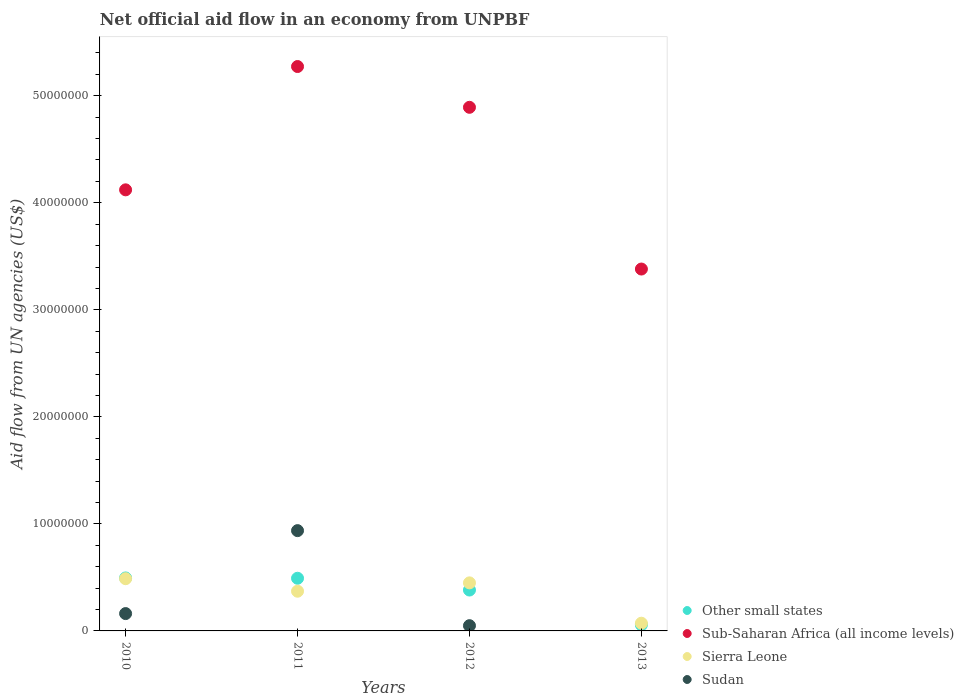Is the number of dotlines equal to the number of legend labels?
Your response must be concise. No. What is the net official aid flow in Sudan in 2011?
Keep it short and to the point. 9.37e+06. Across all years, what is the maximum net official aid flow in Sierra Leone?
Ensure brevity in your answer.  4.88e+06. Across all years, what is the minimum net official aid flow in Sierra Leone?
Provide a short and direct response. 7.20e+05. In which year was the net official aid flow in Sudan maximum?
Keep it short and to the point. 2011. What is the total net official aid flow in Sub-Saharan Africa (all income levels) in the graph?
Offer a very short reply. 1.77e+08. What is the difference between the net official aid flow in Sierra Leone in 2010 and that in 2011?
Make the answer very short. 1.17e+06. What is the difference between the net official aid flow in Sub-Saharan Africa (all income levels) in 2011 and the net official aid flow in Sudan in 2012?
Your response must be concise. 5.22e+07. What is the average net official aid flow in Other small states per year?
Keep it short and to the point. 3.56e+06. In the year 2012, what is the difference between the net official aid flow in Sudan and net official aid flow in Sierra Leone?
Offer a terse response. -4.00e+06. What is the ratio of the net official aid flow in Sierra Leone in 2012 to that in 2013?
Your response must be concise. 6.24. Is the net official aid flow in Other small states in 2012 less than that in 2013?
Keep it short and to the point. No. Is the difference between the net official aid flow in Sudan in 2011 and 2012 greater than the difference between the net official aid flow in Sierra Leone in 2011 and 2012?
Provide a short and direct response. Yes. What is the difference between the highest and the second highest net official aid flow in Sub-Saharan Africa (all income levels)?
Offer a very short reply. 3.81e+06. What is the difference between the highest and the lowest net official aid flow in Other small states?
Offer a terse response. 4.38e+06. Is it the case that in every year, the sum of the net official aid flow in Sierra Leone and net official aid flow in Sudan  is greater than the sum of net official aid flow in Other small states and net official aid flow in Sub-Saharan Africa (all income levels)?
Provide a succinct answer. No. Is the net official aid flow in Sierra Leone strictly less than the net official aid flow in Sub-Saharan Africa (all income levels) over the years?
Keep it short and to the point. Yes. Does the graph contain any zero values?
Your response must be concise. Yes. Does the graph contain grids?
Keep it short and to the point. No. Where does the legend appear in the graph?
Give a very brief answer. Bottom right. How are the legend labels stacked?
Provide a succinct answer. Vertical. What is the title of the graph?
Your answer should be compact. Net official aid flow in an economy from UNPBF. Does "Maldives" appear as one of the legend labels in the graph?
Ensure brevity in your answer.  No. What is the label or title of the X-axis?
Your answer should be very brief. Years. What is the label or title of the Y-axis?
Your answer should be very brief. Aid flow from UN agencies (US$). What is the Aid flow from UN agencies (US$) of Other small states in 2010?
Your response must be concise. 4.95e+06. What is the Aid flow from UN agencies (US$) in Sub-Saharan Africa (all income levels) in 2010?
Your answer should be very brief. 4.12e+07. What is the Aid flow from UN agencies (US$) in Sierra Leone in 2010?
Offer a very short reply. 4.88e+06. What is the Aid flow from UN agencies (US$) in Sudan in 2010?
Ensure brevity in your answer.  1.62e+06. What is the Aid flow from UN agencies (US$) of Other small states in 2011?
Provide a succinct answer. 4.92e+06. What is the Aid flow from UN agencies (US$) in Sub-Saharan Africa (all income levels) in 2011?
Your answer should be very brief. 5.27e+07. What is the Aid flow from UN agencies (US$) in Sierra Leone in 2011?
Your answer should be compact. 3.71e+06. What is the Aid flow from UN agencies (US$) of Sudan in 2011?
Make the answer very short. 9.37e+06. What is the Aid flow from UN agencies (US$) of Other small states in 2012?
Provide a short and direct response. 3.82e+06. What is the Aid flow from UN agencies (US$) in Sub-Saharan Africa (all income levels) in 2012?
Your response must be concise. 4.89e+07. What is the Aid flow from UN agencies (US$) of Sierra Leone in 2012?
Offer a terse response. 4.49e+06. What is the Aid flow from UN agencies (US$) in Sudan in 2012?
Provide a short and direct response. 4.90e+05. What is the Aid flow from UN agencies (US$) of Other small states in 2013?
Make the answer very short. 5.70e+05. What is the Aid flow from UN agencies (US$) of Sub-Saharan Africa (all income levels) in 2013?
Your response must be concise. 3.38e+07. What is the Aid flow from UN agencies (US$) in Sierra Leone in 2013?
Keep it short and to the point. 7.20e+05. Across all years, what is the maximum Aid flow from UN agencies (US$) in Other small states?
Provide a succinct answer. 4.95e+06. Across all years, what is the maximum Aid flow from UN agencies (US$) in Sub-Saharan Africa (all income levels)?
Provide a succinct answer. 5.27e+07. Across all years, what is the maximum Aid flow from UN agencies (US$) of Sierra Leone?
Your answer should be very brief. 4.88e+06. Across all years, what is the maximum Aid flow from UN agencies (US$) in Sudan?
Offer a very short reply. 9.37e+06. Across all years, what is the minimum Aid flow from UN agencies (US$) of Other small states?
Offer a very short reply. 5.70e+05. Across all years, what is the minimum Aid flow from UN agencies (US$) of Sub-Saharan Africa (all income levels)?
Offer a very short reply. 3.38e+07. Across all years, what is the minimum Aid flow from UN agencies (US$) in Sierra Leone?
Keep it short and to the point. 7.20e+05. Across all years, what is the minimum Aid flow from UN agencies (US$) of Sudan?
Provide a short and direct response. 0. What is the total Aid flow from UN agencies (US$) of Other small states in the graph?
Give a very brief answer. 1.43e+07. What is the total Aid flow from UN agencies (US$) of Sub-Saharan Africa (all income levels) in the graph?
Keep it short and to the point. 1.77e+08. What is the total Aid flow from UN agencies (US$) in Sierra Leone in the graph?
Keep it short and to the point. 1.38e+07. What is the total Aid flow from UN agencies (US$) of Sudan in the graph?
Your answer should be very brief. 1.15e+07. What is the difference between the Aid flow from UN agencies (US$) of Other small states in 2010 and that in 2011?
Provide a succinct answer. 3.00e+04. What is the difference between the Aid flow from UN agencies (US$) of Sub-Saharan Africa (all income levels) in 2010 and that in 2011?
Offer a terse response. -1.15e+07. What is the difference between the Aid flow from UN agencies (US$) of Sierra Leone in 2010 and that in 2011?
Offer a very short reply. 1.17e+06. What is the difference between the Aid flow from UN agencies (US$) of Sudan in 2010 and that in 2011?
Make the answer very short. -7.75e+06. What is the difference between the Aid flow from UN agencies (US$) of Other small states in 2010 and that in 2012?
Ensure brevity in your answer.  1.13e+06. What is the difference between the Aid flow from UN agencies (US$) in Sub-Saharan Africa (all income levels) in 2010 and that in 2012?
Offer a terse response. -7.71e+06. What is the difference between the Aid flow from UN agencies (US$) of Sierra Leone in 2010 and that in 2012?
Give a very brief answer. 3.90e+05. What is the difference between the Aid flow from UN agencies (US$) of Sudan in 2010 and that in 2012?
Ensure brevity in your answer.  1.13e+06. What is the difference between the Aid flow from UN agencies (US$) in Other small states in 2010 and that in 2013?
Make the answer very short. 4.38e+06. What is the difference between the Aid flow from UN agencies (US$) of Sub-Saharan Africa (all income levels) in 2010 and that in 2013?
Your response must be concise. 7.40e+06. What is the difference between the Aid flow from UN agencies (US$) of Sierra Leone in 2010 and that in 2013?
Make the answer very short. 4.16e+06. What is the difference between the Aid flow from UN agencies (US$) in Other small states in 2011 and that in 2012?
Give a very brief answer. 1.10e+06. What is the difference between the Aid flow from UN agencies (US$) in Sub-Saharan Africa (all income levels) in 2011 and that in 2012?
Provide a succinct answer. 3.81e+06. What is the difference between the Aid flow from UN agencies (US$) of Sierra Leone in 2011 and that in 2012?
Offer a very short reply. -7.80e+05. What is the difference between the Aid flow from UN agencies (US$) of Sudan in 2011 and that in 2012?
Make the answer very short. 8.88e+06. What is the difference between the Aid flow from UN agencies (US$) of Other small states in 2011 and that in 2013?
Keep it short and to the point. 4.35e+06. What is the difference between the Aid flow from UN agencies (US$) of Sub-Saharan Africa (all income levels) in 2011 and that in 2013?
Provide a succinct answer. 1.89e+07. What is the difference between the Aid flow from UN agencies (US$) in Sierra Leone in 2011 and that in 2013?
Your response must be concise. 2.99e+06. What is the difference between the Aid flow from UN agencies (US$) in Other small states in 2012 and that in 2013?
Your answer should be very brief. 3.25e+06. What is the difference between the Aid flow from UN agencies (US$) of Sub-Saharan Africa (all income levels) in 2012 and that in 2013?
Make the answer very short. 1.51e+07. What is the difference between the Aid flow from UN agencies (US$) of Sierra Leone in 2012 and that in 2013?
Offer a very short reply. 3.77e+06. What is the difference between the Aid flow from UN agencies (US$) in Other small states in 2010 and the Aid flow from UN agencies (US$) in Sub-Saharan Africa (all income levels) in 2011?
Make the answer very short. -4.78e+07. What is the difference between the Aid flow from UN agencies (US$) in Other small states in 2010 and the Aid flow from UN agencies (US$) in Sierra Leone in 2011?
Make the answer very short. 1.24e+06. What is the difference between the Aid flow from UN agencies (US$) in Other small states in 2010 and the Aid flow from UN agencies (US$) in Sudan in 2011?
Provide a succinct answer. -4.42e+06. What is the difference between the Aid flow from UN agencies (US$) in Sub-Saharan Africa (all income levels) in 2010 and the Aid flow from UN agencies (US$) in Sierra Leone in 2011?
Offer a terse response. 3.75e+07. What is the difference between the Aid flow from UN agencies (US$) in Sub-Saharan Africa (all income levels) in 2010 and the Aid flow from UN agencies (US$) in Sudan in 2011?
Your answer should be compact. 3.18e+07. What is the difference between the Aid flow from UN agencies (US$) of Sierra Leone in 2010 and the Aid flow from UN agencies (US$) of Sudan in 2011?
Provide a short and direct response. -4.49e+06. What is the difference between the Aid flow from UN agencies (US$) in Other small states in 2010 and the Aid flow from UN agencies (US$) in Sub-Saharan Africa (all income levels) in 2012?
Your response must be concise. -4.40e+07. What is the difference between the Aid flow from UN agencies (US$) of Other small states in 2010 and the Aid flow from UN agencies (US$) of Sierra Leone in 2012?
Ensure brevity in your answer.  4.60e+05. What is the difference between the Aid flow from UN agencies (US$) of Other small states in 2010 and the Aid flow from UN agencies (US$) of Sudan in 2012?
Your answer should be very brief. 4.46e+06. What is the difference between the Aid flow from UN agencies (US$) in Sub-Saharan Africa (all income levels) in 2010 and the Aid flow from UN agencies (US$) in Sierra Leone in 2012?
Give a very brief answer. 3.67e+07. What is the difference between the Aid flow from UN agencies (US$) in Sub-Saharan Africa (all income levels) in 2010 and the Aid flow from UN agencies (US$) in Sudan in 2012?
Make the answer very short. 4.07e+07. What is the difference between the Aid flow from UN agencies (US$) of Sierra Leone in 2010 and the Aid flow from UN agencies (US$) of Sudan in 2012?
Provide a short and direct response. 4.39e+06. What is the difference between the Aid flow from UN agencies (US$) of Other small states in 2010 and the Aid flow from UN agencies (US$) of Sub-Saharan Africa (all income levels) in 2013?
Provide a succinct answer. -2.89e+07. What is the difference between the Aid flow from UN agencies (US$) in Other small states in 2010 and the Aid flow from UN agencies (US$) in Sierra Leone in 2013?
Provide a short and direct response. 4.23e+06. What is the difference between the Aid flow from UN agencies (US$) in Sub-Saharan Africa (all income levels) in 2010 and the Aid flow from UN agencies (US$) in Sierra Leone in 2013?
Your answer should be compact. 4.05e+07. What is the difference between the Aid flow from UN agencies (US$) in Other small states in 2011 and the Aid flow from UN agencies (US$) in Sub-Saharan Africa (all income levels) in 2012?
Keep it short and to the point. -4.40e+07. What is the difference between the Aid flow from UN agencies (US$) in Other small states in 2011 and the Aid flow from UN agencies (US$) in Sierra Leone in 2012?
Ensure brevity in your answer.  4.30e+05. What is the difference between the Aid flow from UN agencies (US$) in Other small states in 2011 and the Aid flow from UN agencies (US$) in Sudan in 2012?
Offer a very short reply. 4.43e+06. What is the difference between the Aid flow from UN agencies (US$) in Sub-Saharan Africa (all income levels) in 2011 and the Aid flow from UN agencies (US$) in Sierra Leone in 2012?
Give a very brief answer. 4.82e+07. What is the difference between the Aid flow from UN agencies (US$) in Sub-Saharan Africa (all income levels) in 2011 and the Aid flow from UN agencies (US$) in Sudan in 2012?
Ensure brevity in your answer.  5.22e+07. What is the difference between the Aid flow from UN agencies (US$) of Sierra Leone in 2011 and the Aid flow from UN agencies (US$) of Sudan in 2012?
Provide a succinct answer. 3.22e+06. What is the difference between the Aid flow from UN agencies (US$) of Other small states in 2011 and the Aid flow from UN agencies (US$) of Sub-Saharan Africa (all income levels) in 2013?
Provide a succinct answer. -2.89e+07. What is the difference between the Aid flow from UN agencies (US$) in Other small states in 2011 and the Aid flow from UN agencies (US$) in Sierra Leone in 2013?
Your response must be concise. 4.20e+06. What is the difference between the Aid flow from UN agencies (US$) in Sub-Saharan Africa (all income levels) in 2011 and the Aid flow from UN agencies (US$) in Sierra Leone in 2013?
Provide a short and direct response. 5.20e+07. What is the difference between the Aid flow from UN agencies (US$) in Other small states in 2012 and the Aid flow from UN agencies (US$) in Sub-Saharan Africa (all income levels) in 2013?
Give a very brief answer. -3.00e+07. What is the difference between the Aid flow from UN agencies (US$) in Other small states in 2012 and the Aid flow from UN agencies (US$) in Sierra Leone in 2013?
Provide a short and direct response. 3.10e+06. What is the difference between the Aid flow from UN agencies (US$) in Sub-Saharan Africa (all income levels) in 2012 and the Aid flow from UN agencies (US$) in Sierra Leone in 2013?
Offer a very short reply. 4.82e+07. What is the average Aid flow from UN agencies (US$) in Other small states per year?
Keep it short and to the point. 3.56e+06. What is the average Aid flow from UN agencies (US$) of Sub-Saharan Africa (all income levels) per year?
Give a very brief answer. 4.42e+07. What is the average Aid flow from UN agencies (US$) of Sierra Leone per year?
Give a very brief answer. 3.45e+06. What is the average Aid flow from UN agencies (US$) in Sudan per year?
Your answer should be very brief. 2.87e+06. In the year 2010, what is the difference between the Aid flow from UN agencies (US$) in Other small states and Aid flow from UN agencies (US$) in Sub-Saharan Africa (all income levels)?
Offer a terse response. -3.63e+07. In the year 2010, what is the difference between the Aid flow from UN agencies (US$) of Other small states and Aid flow from UN agencies (US$) of Sierra Leone?
Provide a succinct answer. 7.00e+04. In the year 2010, what is the difference between the Aid flow from UN agencies (US$) in Other small states and Aid flow from UN agencies (US$) in Sudan?
Your response must be concise. 3.33e+06. In the year 2010, what is the difference between the Aid flow from UN agencies (US$) of Sub-Saharan Africa (all income levels) and Aid flow from UN agencies (US$) of Sierra Leone?
Make the answer very short. 3.63e+07. In the year 2010, what is the difference between the Aid flow from UN agencies (US$) of Sub-Saharan Africa (all income levels) and Aid flow from UN agencies (US$) of Sudan?
Give a very brief answer. 3.96e+07. In the year 2010, what is the difference between the Aid flow from UN agencies (US$) in Sierra Leone and Aid flow from UN agencies (US$) in Sudan?
Offer a terse response. 3.26e+06. In the year 2011, what is the difference between the Aid flow from UN agencies (US$) of Other small states and Aid flow from UN agencies (US$) of Sub-Saharan Africa (all income levels)?
Your answer should be compact. -4.78e+07. In the year 2011, what is the difference between the Aid flow from UN agencies (US$) in Other small states and Aid flow from UN agencies (US$) in Sierra Leone?
Your response must be concise. 1.21e+06. In the year 2011, what is the difference between the Aid flow from UN agencies (US$) of Other small states and Aid flow from UN agencies (US$) of Sudan?
Ensure brevity in your answer.  -4.45e+06. In the year 2011, what is the difference between the Aid flow from UN agencies (US$) in Sub-Saharan Africa (all income levels) and Aid flow from UN agencies (US$) in Sierra Leone?
Your answer should be compact. 4.90e+07. In the year 2011, what is the difference between the Aid flow from UN agencies (US$) of Sub-Saharan Africa (all income levels) and Aid flow from UN agencies (US$) of Sudan?
Your answer should be compact. 4.34e+07. In the year 2011, what is the difference between the Aid flow from UN agencies (US$) in Sierra Leone and Aid flow from UN agencies (US$) in Sudan?
Your response must be concise. -5.66e+06. In the year 2012, what is the difference between the Aid flow from UN agencies (US$) in Other small states and Aid flow from UN agencies (US$) in Sub-Saharan Africa (all income levels)?
Provide a succinct answer. -4.51e+07. In the year 2012, what is the difference between the Aid flow from UN agencies (US$) in Other small states and Aid flow from UN agencies (US$) in Sierra Leone?
Provide a succinct answer. -6.70e+05. In the year 2012, what is the difference between the Aid flow from UN agencies (US$) in Other small states and Aid flow from UN agencies (US$) in Sudan?
Your answer should be compact. 3.33e+06. In the year 2012, what is the difference between the Aid flow from UN agencies (US$) of Sub-Saharan Africa (all income levels) and Aid flow from UN agencies (US$) of Sierra Leone?
Offer a terse response. 4.44e+07. In the year 2012, what is the difference between the Aid flow from UN agencies (US$) in Sub-Saharan Africa (all income levels) and Aid flow from UN agencies (US$) in Sudan?
Your answer should be very brief. 4.84e+07. In the year 2013, what is the difference between the Aid flow from UN agencies (US$) of Other small states and Aid flow from UN agencies (US$) of Sub-Saharan Africa (all income levels)?
Provide a succinct answer. -3.32e+07. In the year 2013, what is the difference between the Aid flow from UN agencies (US$) of Other small states and Aid flow from UN agencies (US$) of Sierra Leone?
Ensure brevity in your answer.  -1.50e+05. In the year 2013, what is the difference between the Aid flow from UN agencies (US$) of Sub-Saharan Africa (all income levels) and Aid flow from UN agencies (US$) of Sierra Leone?
Provide a short and direct response. 3.31e+07. What is the ratio of the Aid flow from UN agencies (US$) in Sub-Saharan Africa (all income levels) in 2010 to that in 2011?
Give a very brief answer. 0.78. What is the ratio of the Aid flow from UN agencies (US$) of Sierra Leone in 2010 to that in 2011?
Your answer should be compact. 1.32. What is the ratio of the Aid flow from UN agencies (US$) of Sudan in 2010 to that in 2011?
Offer a very short reply. 0.17. What is the ratio of the Aid flow from UN agencies (US$) in Other small states in 2010 to that in 2012?
Keep it short and to the point. 1.3. What is the ratio of the Aid flow from UN agencies (US$) in Sub-Saharan Africa (all income levels) in 2010 to that in 2012?
Make the answer very short. 0.84. What is the ratio of the Aid flow from UN agencies (US$) in Sierra Leone in 2010 to that in 2012?
Provide a short and direct response. 1.09. What is the ratio of the Aid flow from UN agencies (US$) in Sudan in 2010 to that in 2012?
Keep it short and to the point. 3.31. What is the ratio of the Aid flow from UN agencies (US$) in Other small states in 2010 to that in 2013?
Provide a succinct answer. 8.68. What is the ratio of the Aid flow from UN agencies (US$) of Sub-Saharan Africa (all income levels) in 2010 to that in 2013?
Offer a very short reply. 1.22. What is the ratio of the Aid flow from UN agencies (US$) of Sierra Leone in 2010 to that in 2013?
Provide a succinct answer. 6.78. What is the ratio of the Aid flow from UN agencies (US$) in Other small states in 2011 to that in 2012?
Your response must be concise. 1.29. What is the ratio of the Aid flow from UN agencies (US$) of Sub-Saharan Africa (all income levels) in 2011 to that in 2012?
Give a very brief answer. 1.08. What is the ratio of the Aid flow from UN agencies (US$) in Sierra Leone in 2011 to that in 2012?
Offer a terse response. 0.83. What is the ratio of the Aid flow from UN agencies (US$) in Sudan in 2011 to that in 2012?
Keep it short and to the point. 19.12. What is the ratio of the Aid flow from UN agencies (US$) in Other small states in 2011 to that in 2013?
Your response must be concise. 8.63. What is the ratio of the Aid flow from UN agencies (US$) of Sub-Saharan Africa (all income levels) in 2011 to that in 2013?
Give a very brief answer. 1.56. What is the ratio of the Aid flow from UN agencies (US$) in Sierra Leone in 2011 to that in 2013?
Your response must be concise. 5.15. What is the ratio of the Aid flow from UN agencies (US$) of Other small states in 2012 to that in 2013?
Your response must be concise. 6.7. What is the ratio of the Aid flow from UN agencies (US$) of Sub-Saharan Africa (all income levels) in 2012 to that in 2013?
Give a very brief answer. 1.45. What is the ratio of the Aid flow from UN agencies (US$) in Sierra Leone in 2012 to that in 2013?
Provide a short and direct response. 6.24. What is the difference between the highest and the second highest Aid flow from UN agencies (US$) of Sub-Saharan Africa (all income levels)?
Make the answer very short. 3.81e+06. What is the difference between the highest and the second highest Aid flow from UN agencies (US$) of Sudan?
Your response must be concise. 7.75e+06. What is the difference between the highest and the lowest Aid flow from UN agencies (US$) of Other small states?
Offer a terse response. 4.38e+06. What is the difference between the highest and the lowest Aid flow from UN agencies (US$) of Sub-Saharan Africa (all income levels)?
Your response must be concise. 1.89e+07. What is the difference between the highest and the lowest Aid flow from UN agencies (US$) of Sierra Leone?
Your response must be concise. 4.16e+06. What is the difference between the highest and the lowest Aid flow from UN agencies (US$) in Sudan?
Ensure brevity in your answer.  9.37e+06. 